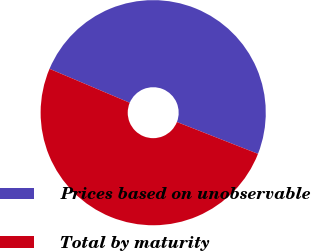<chart> <loc_0><loc_0><loc_500><loc_500><pie_chart><fcel>Prices based on unobservable<fcel>Total by maturity<nl><fcel>49.59%<fcel>50.41%<nl></chart> 